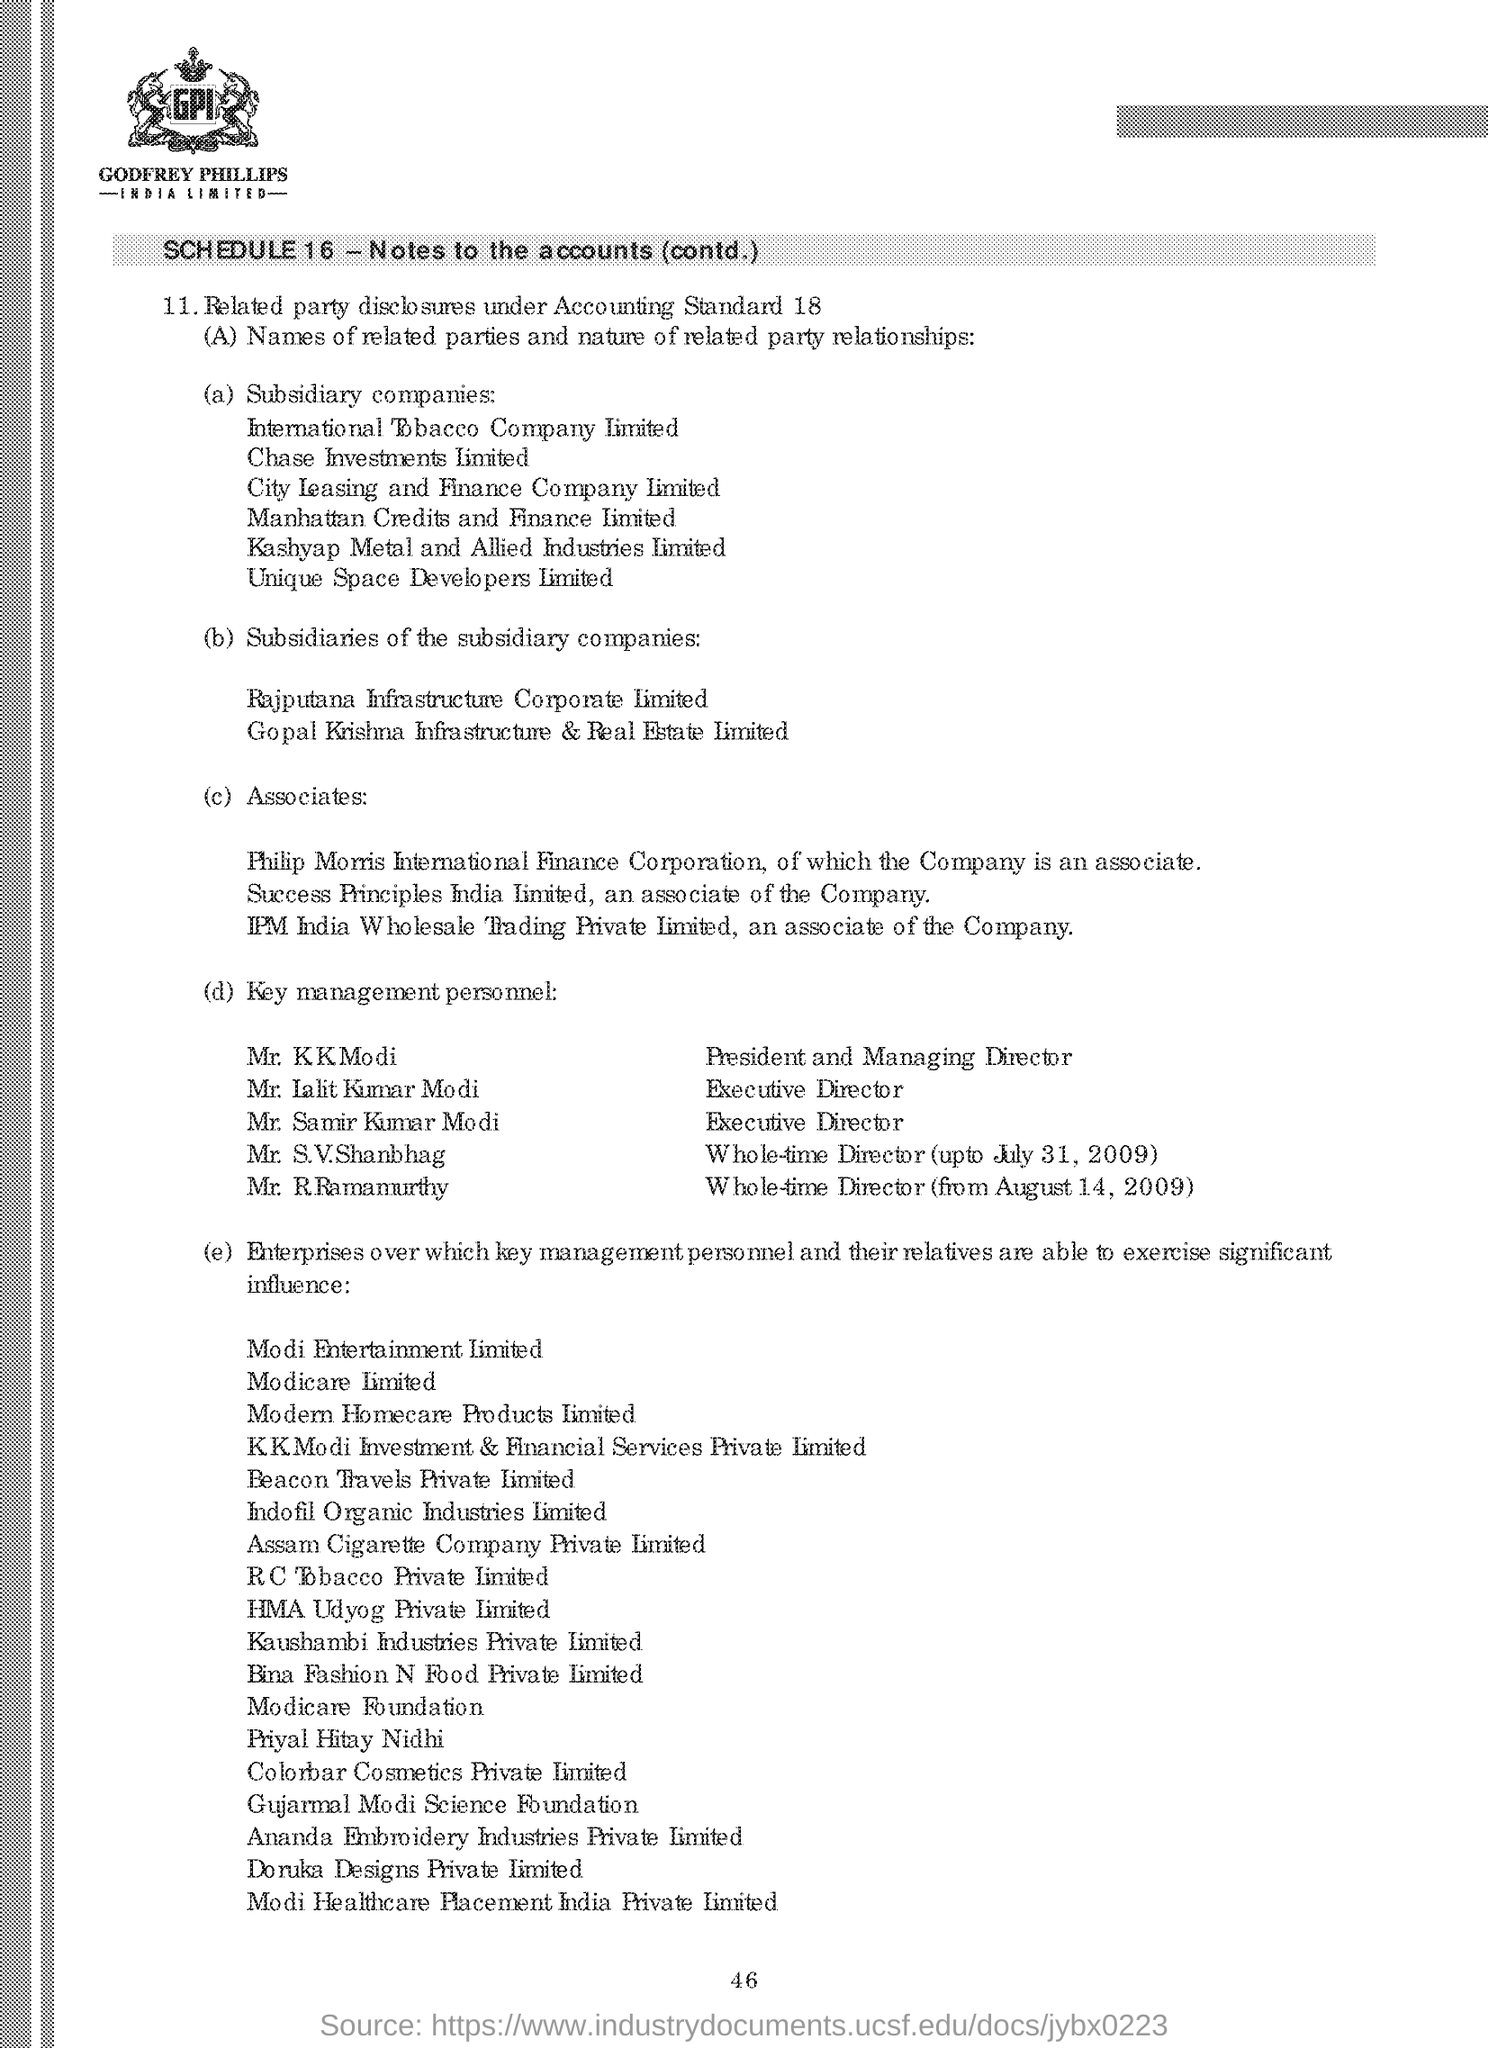Who is the president and managing director as shown in the given page ?
Offer a very short reply. Mr. K K Modi. Who is the whole -time director( up to july 31,2009) ?
Make the answer very short. Mr. S.V.Shanbhag. Who is the whole-time director (from august 14,2009) ?
Offer a very short reply. Mr. R Ramamurthy. 